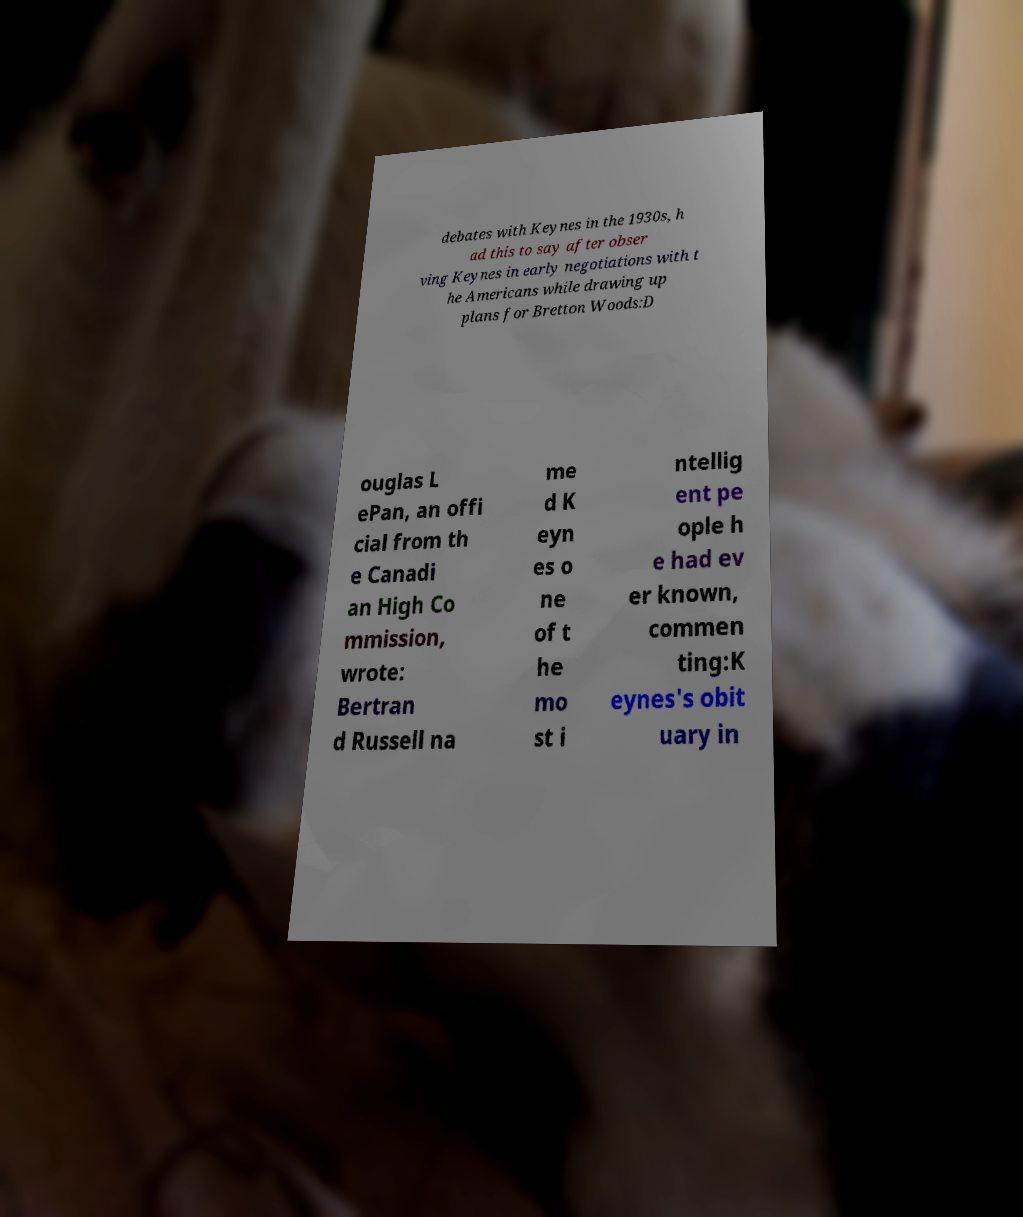Can you accurately transcribe the text from the provided image for me? debates with Keynes in the 1930s, h ad this to say after obser ving Keynes in early negotiations with t he Americans while drawing up plans for Bretton Woods:D ouglas L ePan, an offi cial from th e Canadi an High Co mmission, wrote: Bertran d Russell na me d K eyn es o ne of t he mo st i ntellig ent pe ople h e had ev er known, commen ting:K eynes's obit uary in 